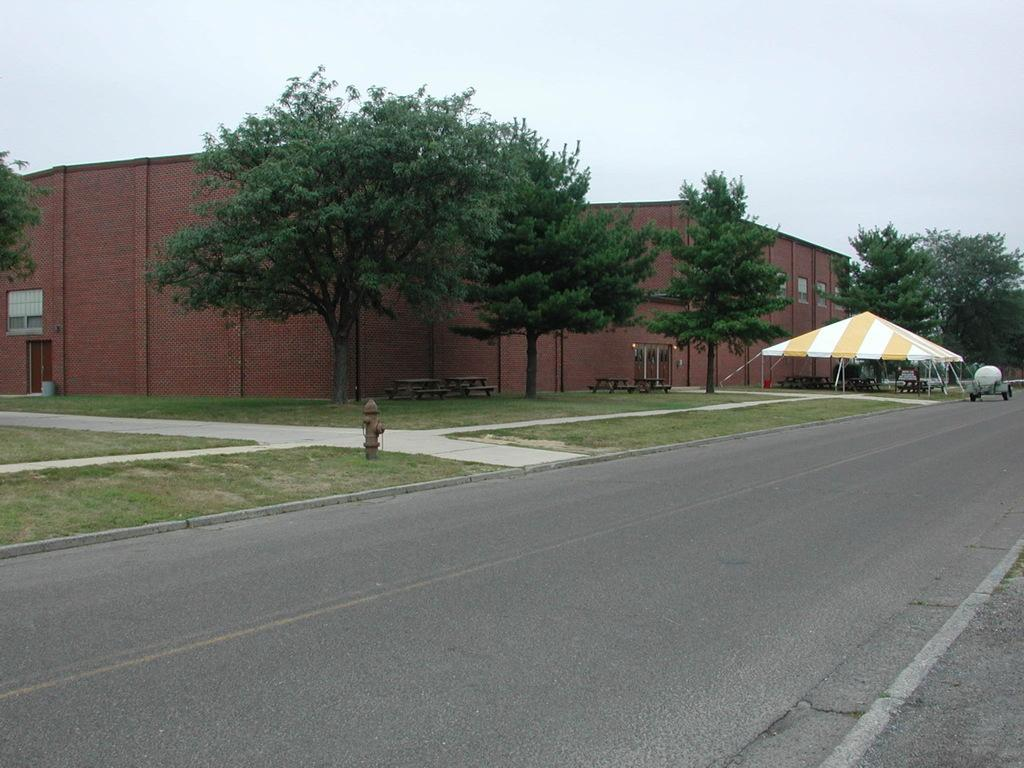What object can be seen in the image that is used for fire safety? There is a fire hydrant in the image. What type of natural environment is visible in the image? There is grass, trees, and the sky visible in the image. What type of shelter is present in the image? There is a tent in the image. What type of transportation is visible in the image? There is a vehicle on the road in the image. What type of structure is present in the image? There is a building in the image. What type of seating is available in the image? There are benches in the image. Where is the library located in the image? There is no library present in the image. What type of liquid is being poured from the fire hydrant in the image? There is no liquid being poured from the fire hydrant in the image; it is a stationary object. 